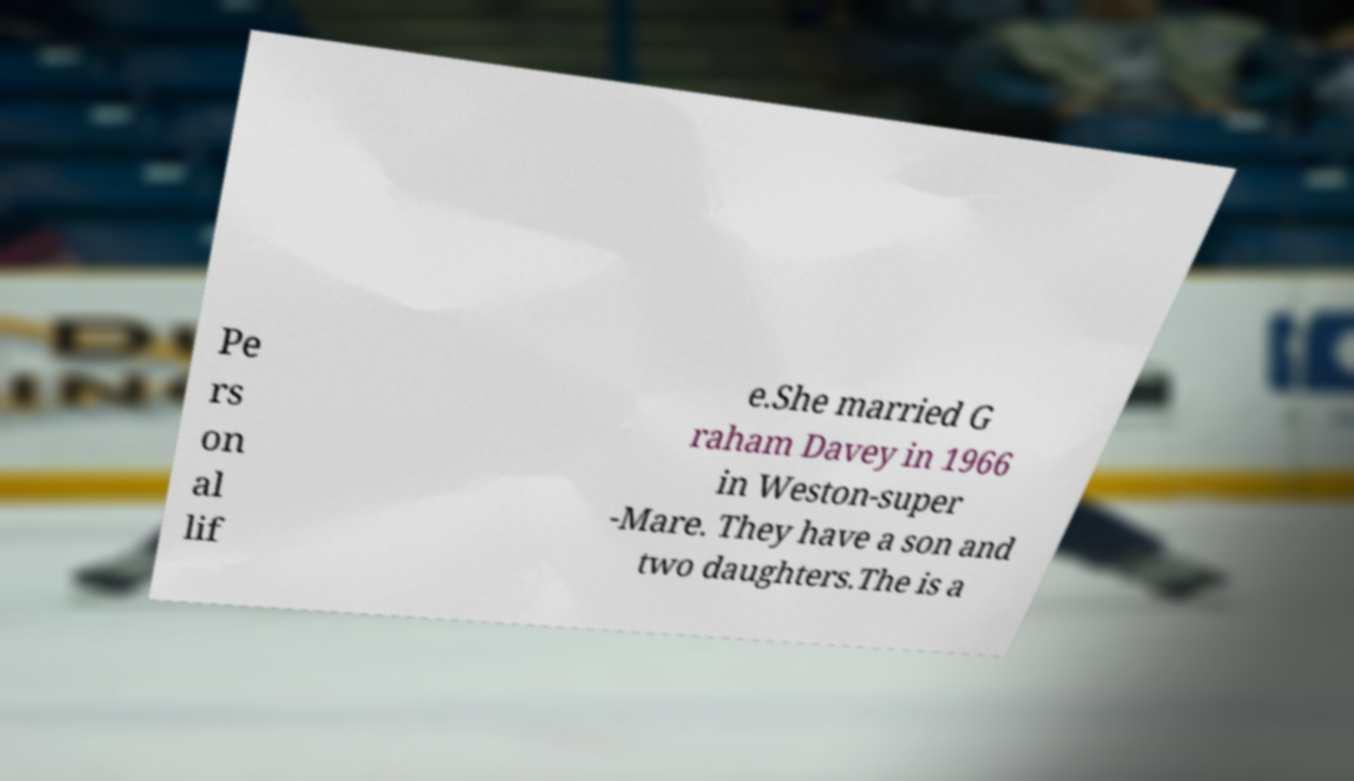For documentation purposes, I need the text within this image transcribed. Could you provide that? Pe rs on al lif e.She married G raham Davey in 1966 in Weston-super -Mare. They have a son and two daughters.The is a 